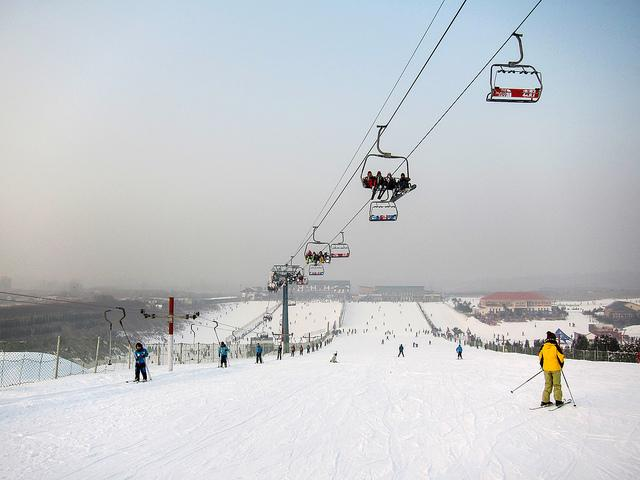What would happen if you cut the top wires? lifts fall 